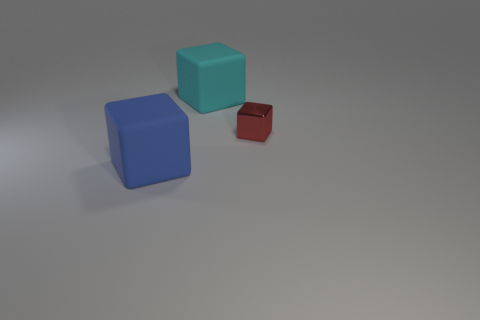There is a rubber cube that is to the right of the large rubber cube in front of the cyan object; how big is it?
Provide a short and direct response. Large. There is a blue block that is made of the same material as the large cyan thing; what size is it?
Offer a very short reply. Large. There is a thing that is both behind the large blue cube and left of the metallic object; what shape is it?
Your response must be concise. Cube. Are there the same number of tiny red metal objects that are to the right of the metal block and big brown metallic balls?
Your response must be concise. Yes. What number of things are either small metallic things or small things that are behind the blue thing?
Offer a very short reply. 1. Are there any other blue rubber objects that have the same shape as the tiny object?
Provide a succinct answer. Yes. Is the number of blue matte things right of the big cyan thing the same as the number of tiny cubes that are to the right of the big blue cube?
Your answer should be very brief. No. Is there any other thing that is the same size as the cyan thing?
Offer a very short reply. Yes. What number of purple objects are either tiny things or large rubber objects?
Your response must be concise. 0. What number of cubes are the same size as the blue rubber thing?
Ensure brevity in your answer.  1. 